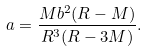Convert formula to latex. <formula><loc_0><loc_0><loc_500><loc_500>a = \frac { M b ^ { 2 } ( R - M ) } { R ^ { 3 } ( R - 3 M ) } .</formula> 